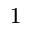<formula> <loc_0><loc_0><loc_500><loc_500>^ { 1 }</formula> 